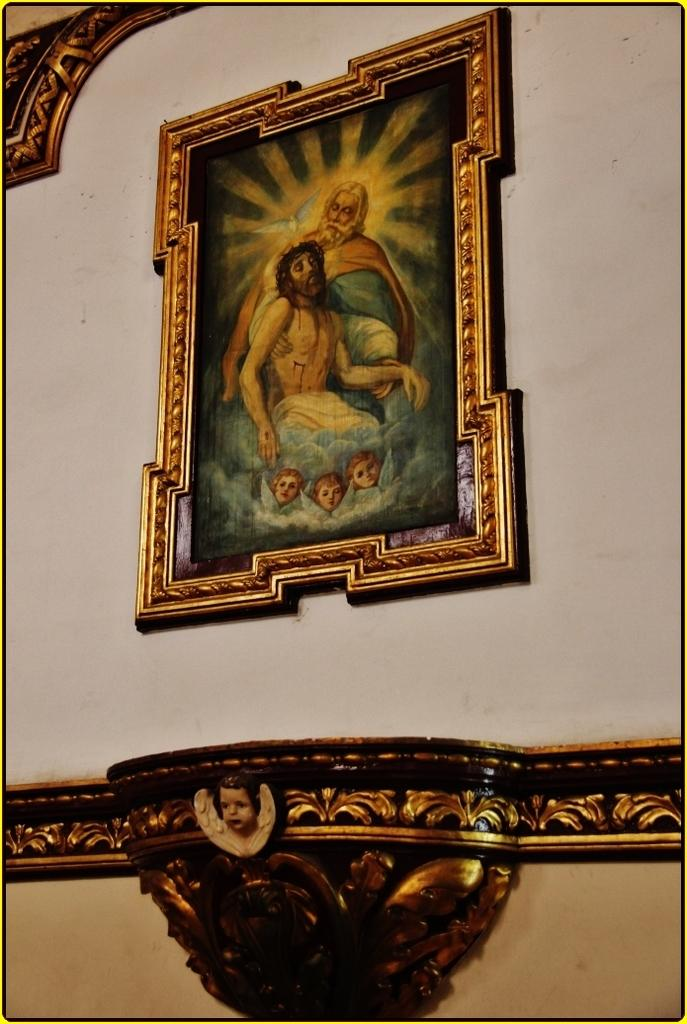What is the color of the wall in the image? There is a white wall in the image. What is hanging on the wall? There is a painting on the wall. How is the painting framed? The painting is in a golden color frame. What is the subject of the painting? The painting depicts the face of a child. Are there any ants crawling on the edge of the painting in the image? There are no ants present in the image, and the edge of the painting is not mentioned in the provided facts. 